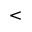<formula> <loc_0><loc_0><loc_500><loc_500><</formula> 